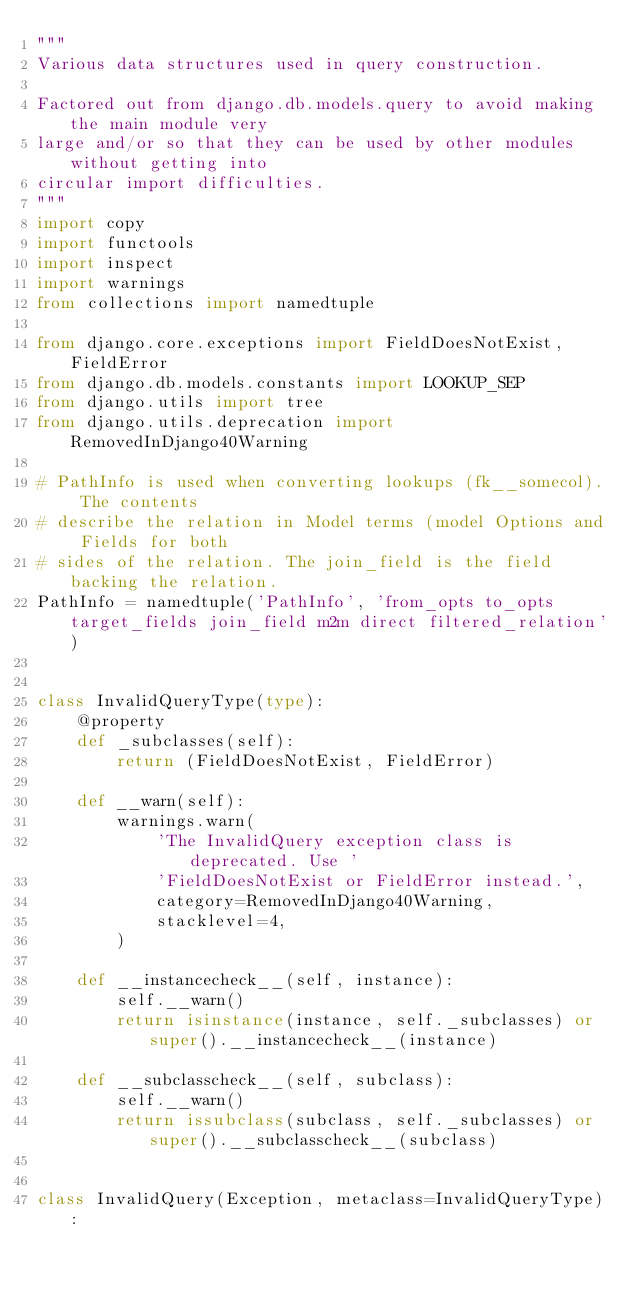<code> <loc_0><loc_0><loc_500><loc_500><_Python_>"""
Various data structures used in query construction.

Factored out from django.db.models.query to avoid making the main module very
large and/or so that they can be used by other modules without getting into
circular import difficulties.
"""
import copy
import functools
import inspect
import warnings
from collections import namedtuple

from django.core.exceptions import FieldDoesNotExist, FieldError
from django.db.models.constants import LOOKUP_SEP
from django.utils import tree
from django.utils.deprecation import RemovedInDjango40Warning

# PathInfo is used when converting lookups (fk__somecol). The contents
# describe the relation in Model terms (model Options and Fields for both
# sides of the relation. The join_field is the field backing the relation.
PathInfo = namedtuple('PathInfo', 'from_opts to_opts target_fields join_field m2m direct filtered_relation')


class InvalidQueryType(type):
    @property
    def _subclasses(self):
        return (FieldDoesNotExist, FieldError)

    def __warn(self):
        warnings.warn(
            'The InvalidQuery exception class is deprecated. Use '
            'FieldDoesNotExist or FieldError instead.',
            category=RemovedInDjango40Warning,
            stacklevel=4,
        )

    def __instancecheck__(self, instance):
        self.__warn()
        return isinstance(instance, self._subclasses) or super().__instancecheck__(instance)

    def __subclasscheck__(self, subclass):
        self.__warn()
        return issubclass(subclass, self._subclasses) or super().__subclasscheck__(subclass)


class InvalidQuery(Exception, metaclass=InvalidQueryType):</code> 